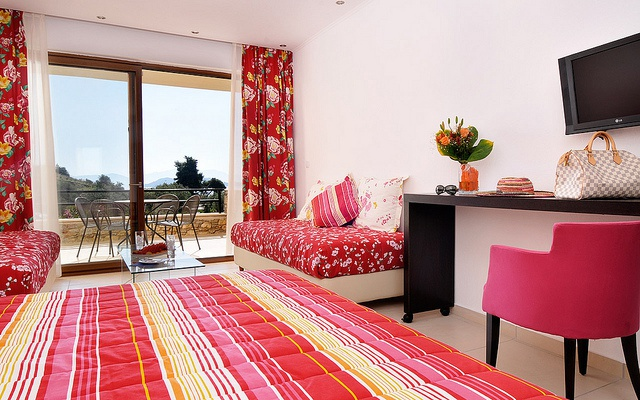Describe the objects in this image and their specific colors. I can see bed in darkgray, white, salmon, red, and lightpink tones, chair in salmon, brown, and maroon tones, couch in darkgray, lightpink, lightgray, brown, and salmon tones, bed in salmon, lightgray, lightpink, and brown tones, and tv in darkgray, black, gray, and lightgray tones in this image. 